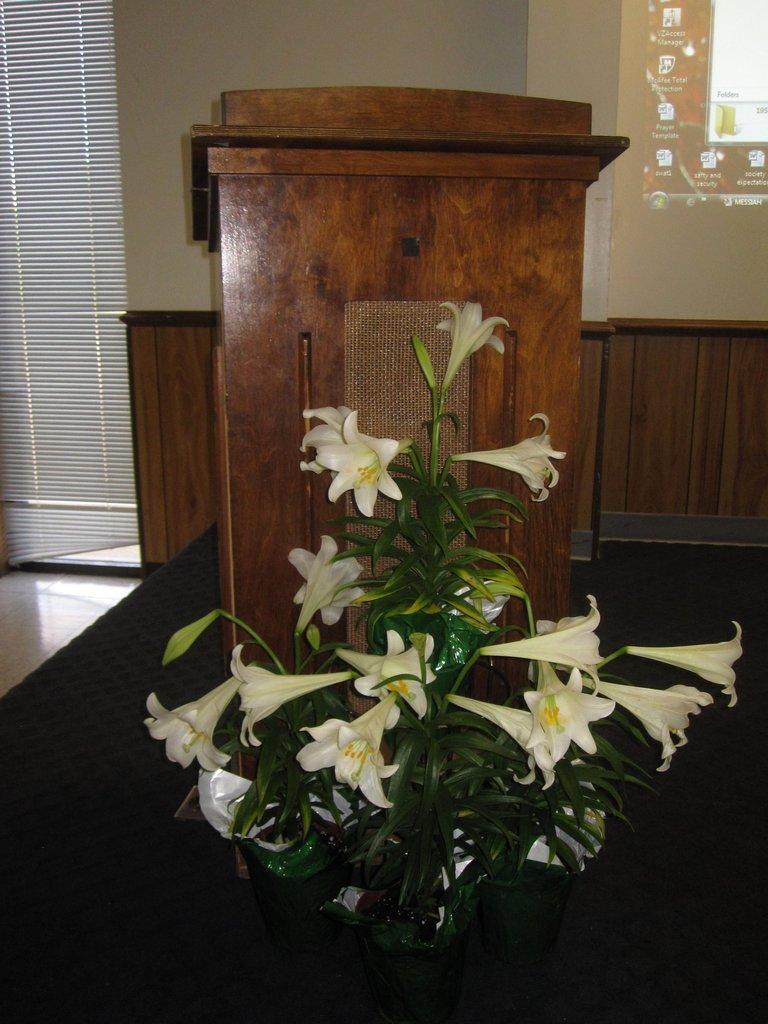Could you give a brief overview of what you see in this image? There are flowers and a wooden desk in the foreground area of the image, it seems like a window and a screen in the background. 